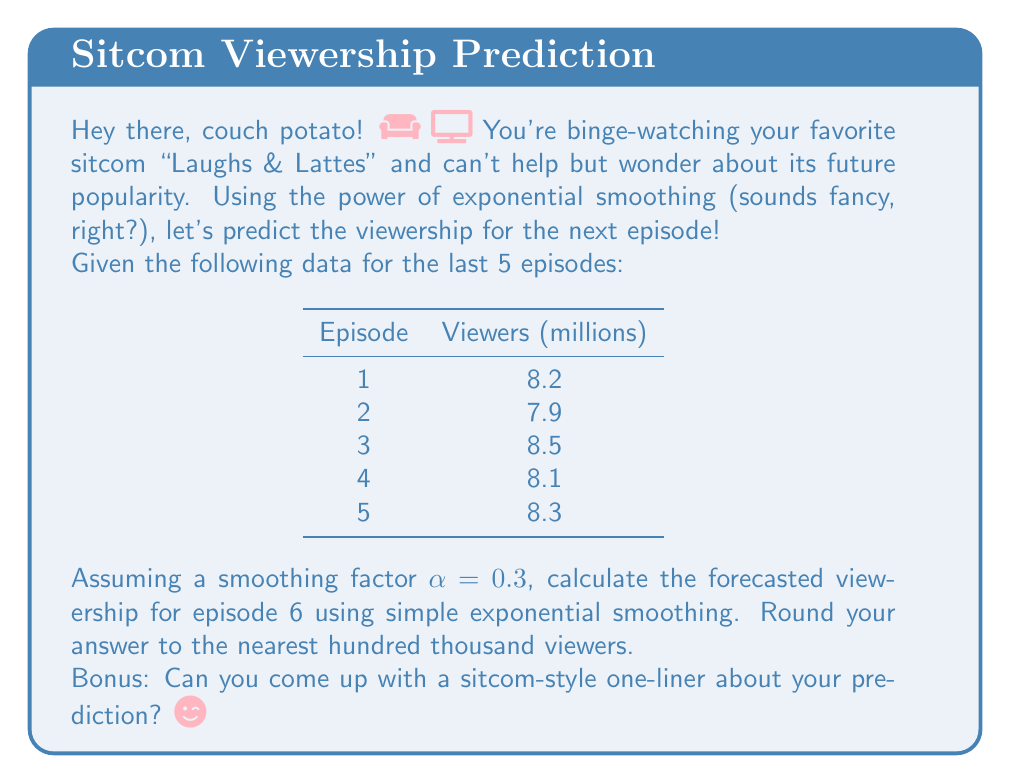Teach me how to tackle this problem. Alright, fellow sitcom enthusiast, let's break this down step-by-step:

1) The formula for simple exponential smoothing is:
   $$F_{t+1} = \alpha Y_t + (1-\alpha)F_t$$
   Where:
   $F_{t+1}$ is the forecast for the next period
   $\alpha$ is the smoothing factor (0.3 in this case)
   $Y_t$ is the actual value for the current period
   $F_t$ is the forecast for the current period

2) We start by setting $F_1 = Y_1 = 8.2$ million viewers

3) Let's calculate each forecast:
   
   For episode 2:
   $$F_2 = 0.3(8.2) + 0.7(8.2) = 8.2$$

   For episode 3:
   $$F_3 = 0.3(7.9) + 0.7(8.2) = 8.11$$

   For episode 4:
   $$F_4 = 0.3(8.5) + 0.7(8.11) = 8.227$$

   For episode 5:
   $$F_5 = 0.3(8.1) + 0.7(8.227) = 8.1889$$

4) Now, for the forecast of episode 6:
   $$F_6 = 0.3(8.3) + 0.7(8.1889) = 8.22223$$

5) Rounding to the nearest hundred thousand:
   8.22223 million ≈ 8.2 million viewers

Bonus one-liner: "Looks like 'Laughs & Lattes' is brewing up a storm – the viewership forecast is grounds for celebration!" ☕😄
Answer: 8.2 million viewers 